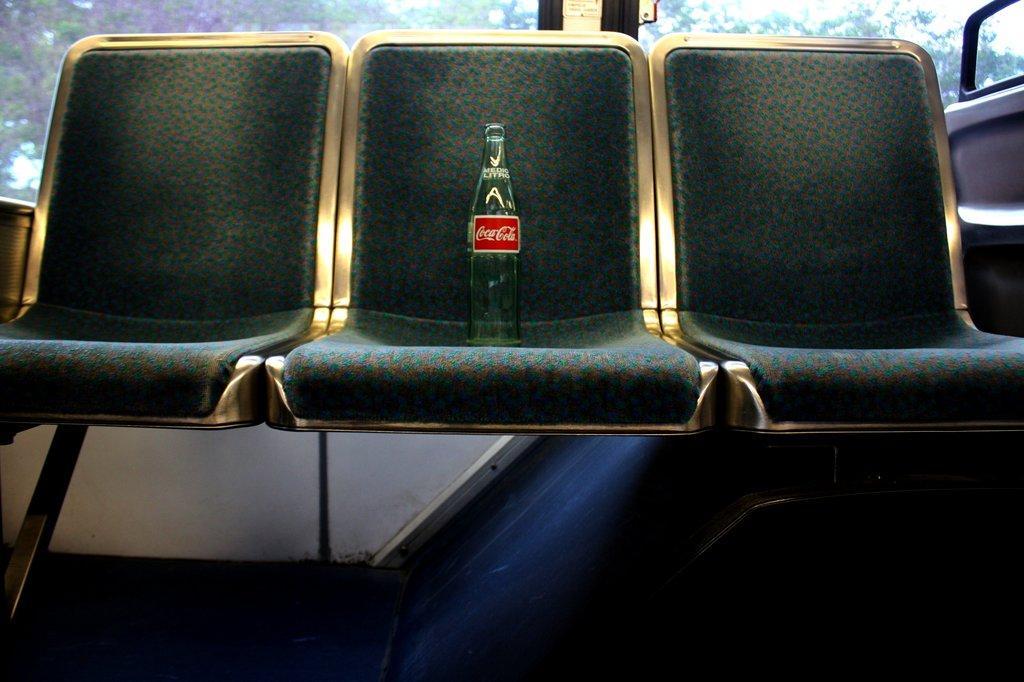How would you summarize this image in a sentence or two? In this picture I can see there are few chairs and there is a beverage bottle placed at the center. In the backdrop there is a window and there are trees visible from the window. 